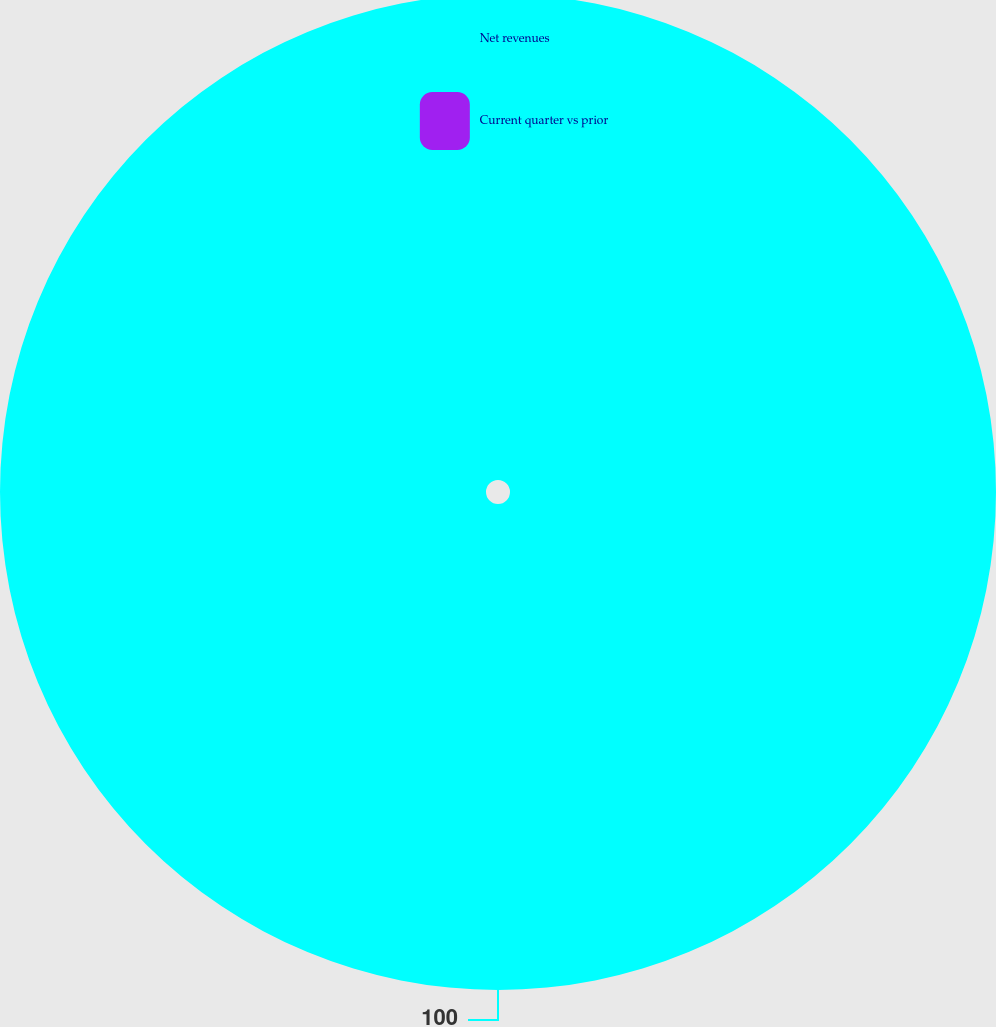Convert chart to OTSL. <chart><loc_0><loc_0><loc_500><loc_500><pie_chart><fcel>Net revenues<fcel>Current quarter vs prior<nl><fcel>100.0%<fcel>0.0%<nl></chart> 